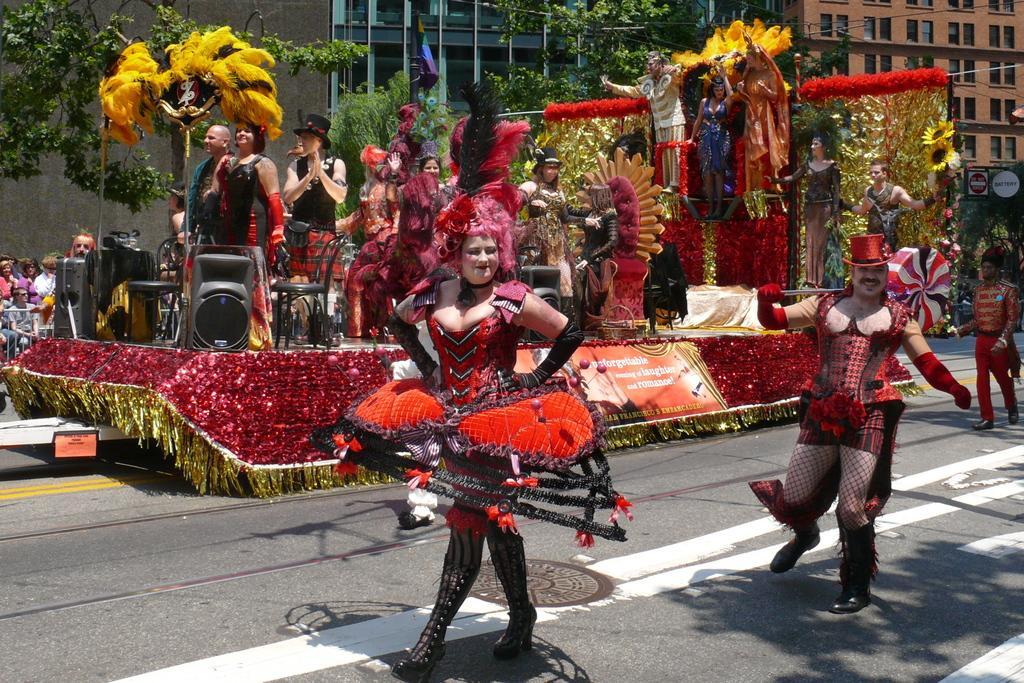Please provide a concise description of this image. In this image there are some persons performing on the stage as e we can see in the middle of this image. There are some persons standing on the road in the bottom of this image. There are some trees in the background. There are some buildings on the top of this image. There are some persons sitting on the left side of this image. 